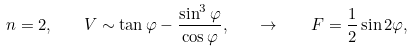Convert formula to latex. <formula><loc_0><loc_0><loc_500><loc_500>n = 2 , \quad V \sim \tan \varphi - \frac { \sin ^ { 3 } \varphi } { \cos \varphi } , \quad \rightarrow \quad F = \frac { 1 } { 2 } \sin { 2 \varphi } ,</formula> 